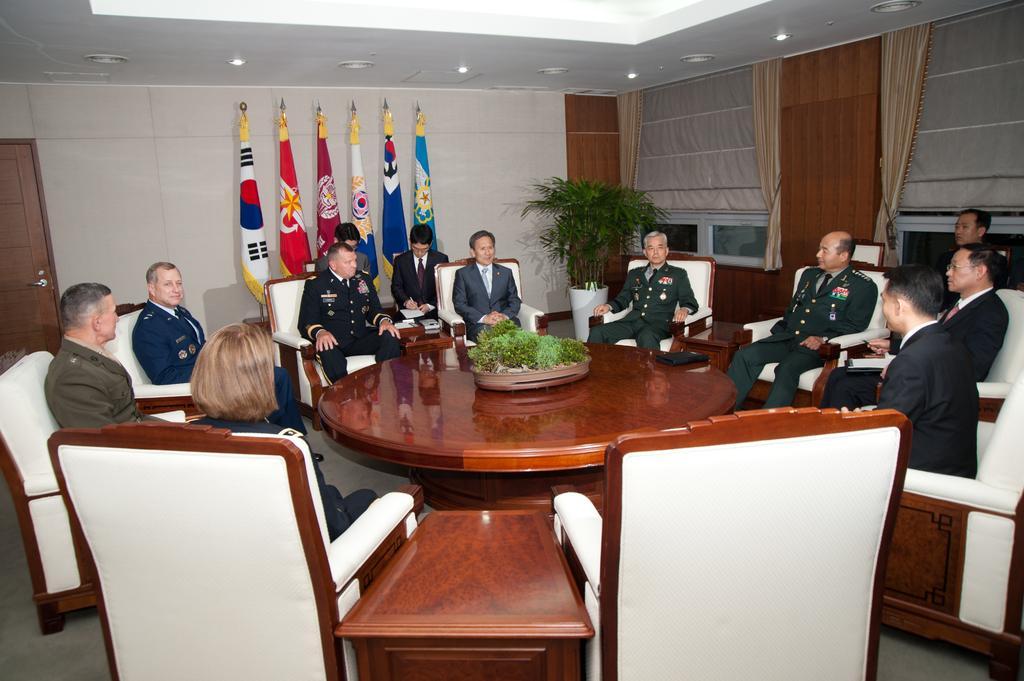In one or two sentences, can you explain what this image depicts? This picture is clicked inside the room. Here, we see many people sitting on chair around a brown table on which a bowl containing grass is placed. Behind them, we see six flags and a white wall and on the right corner of the picture, we see curtain in light brown color. 